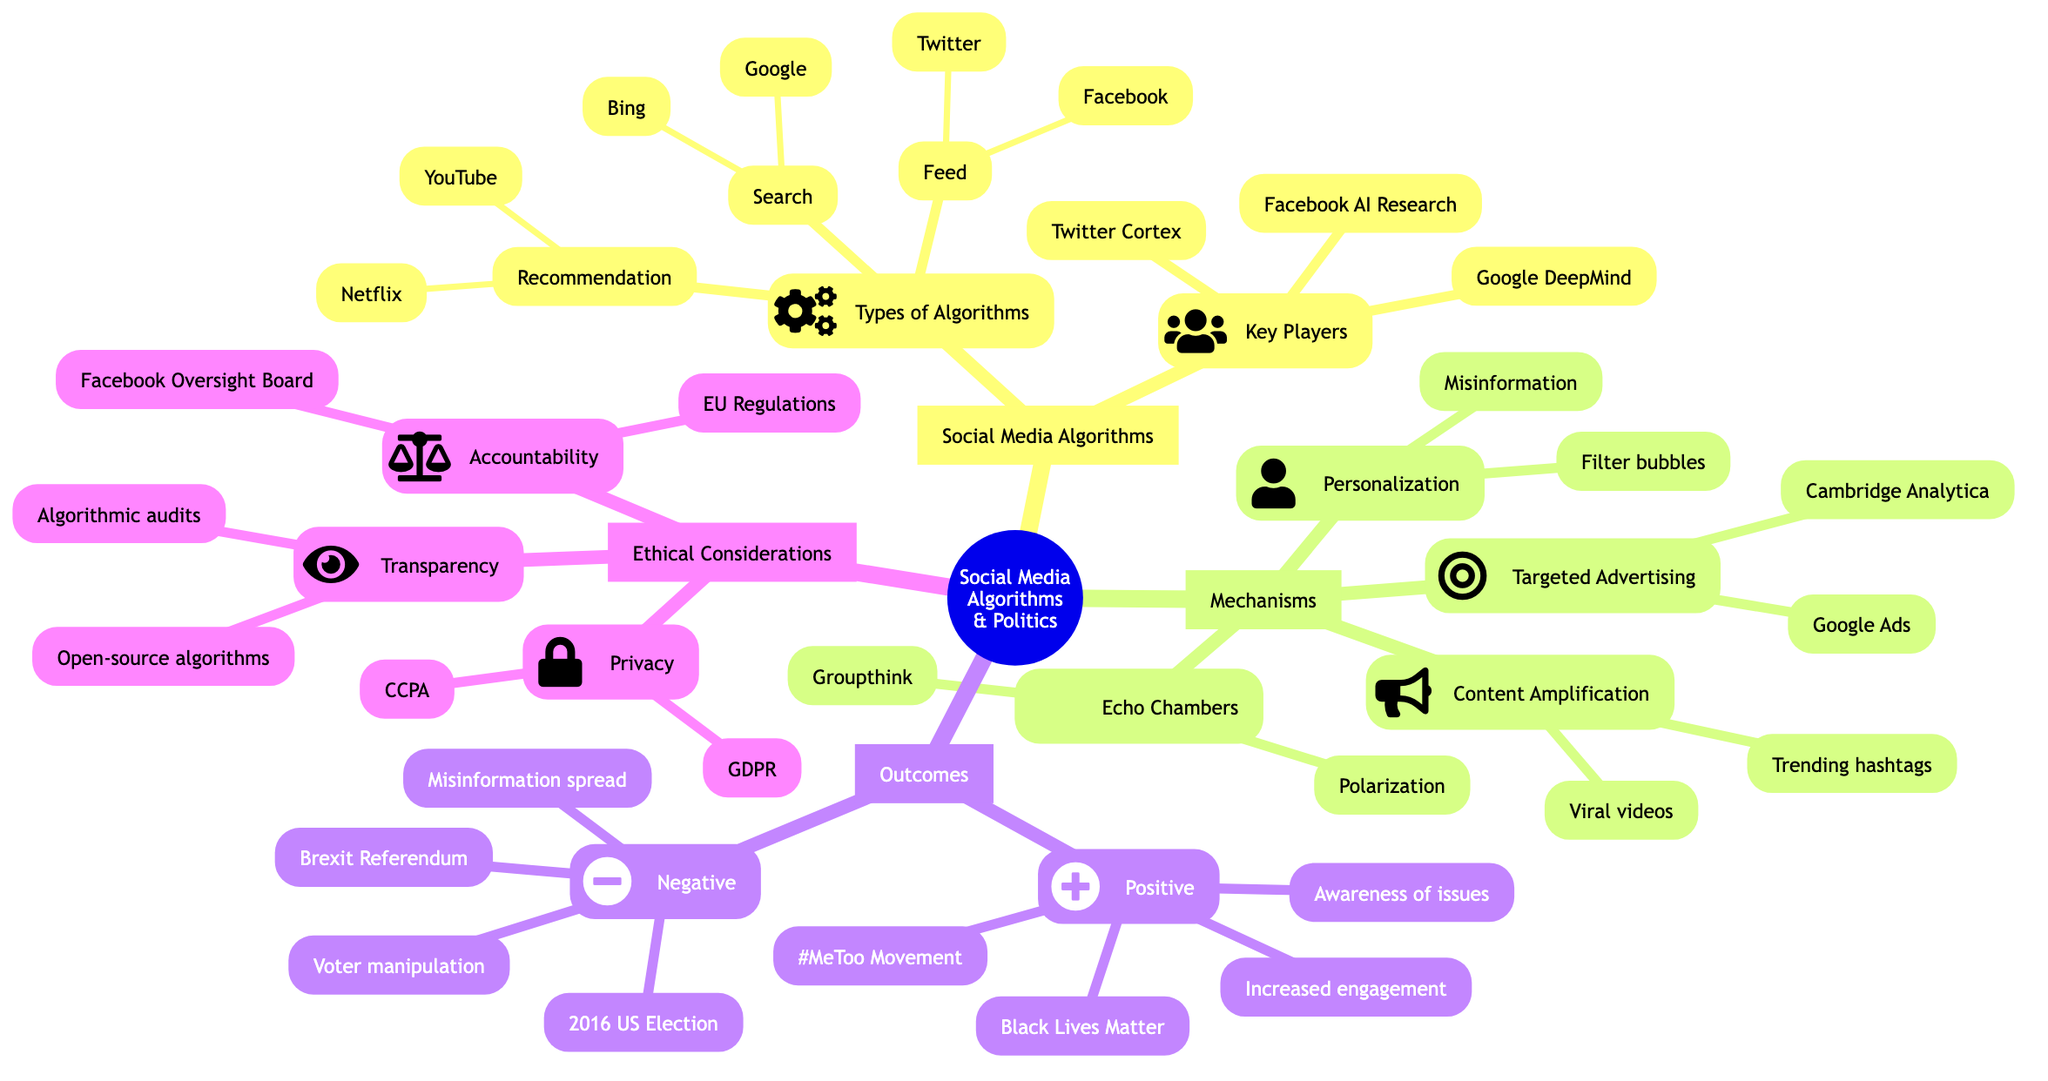What are the types of algorithms listed under social media algorithms? The subnodes under "Types of Algorithms" are "Recommendation Algorithms," "Search Algorithms," and "Feed Algorithms." These are explicitly stated under the node "Types of Algorithms."
Answer: Recommendation Algorithms, Search Algorithms, Feed Algorithms Which platforms are associated with recommendation algorithms? The diagram specifies "YouTube" and "Netflix" as platforms that use recommendation algorithms listed under the "Types of Algorithms" node and its subnode "Recommendation Algorithms."
Answer: YouTube, Netflix What is one example of content amplification mentioned in the diagram? The diagram lists examples under "Content Amplification," specifying "Trending hashtags on Twitter" and "Viral videos on YouTube." As the question asks for one example, either could suffice, but we'll choose the first one as listed.
Answer: Trending hashtags on Twitter What are the two negative outcomes associated with algorithmic influence on political movements? The subnode under "Negative Outcomes" lists "Spread of misinformation" and "Manipulation of voter behavior." Both are specified directly under the corresponding node.
Answer: Spread of misinformation, Manipulation of voter behavior What ethical consideration is focused on user data protection? Under "Ethical Considerations," the subnode "Privacy" explicitly mentions user data protection, which is the focus of this node. This is clearly stated, making it straightforward to answer.
Answer: Privacy How many key players are listed under social media algorithms? The "Key Players" node contains three entities: "Facebook AI Research," "Google DeepMind," and "Twitter Cortex." Counting these entities gives the total number of key players.
Answer: 3 Which case study examples are provided under positive outcomes? The examples listed under "Positive Outcomes" include "#MeToo Movement" and "Black Lives Matter." Both are explicitly stated under this node, indicating the positive case studies.
Answer: #MeToo Movement, Black Lives Matter What suggestion is made regarding transparency in ethical considerations? The node for "Transparency" under "Ethical Considerations" suggests "Algorithmic audits" and "Open-source algorithms" as ways to improve transparency, specifically stating these suggestions.
Answer: Algorithmic audits, Open-source algorithms What description is given for echo chambers? The "Echo Chambers" subnode describes how algorithms reinforce users' pre-existing beliefs, which leads to effects like polarization and groupthink. This description is explicitly provided in the diagram.
Answer: Algorithms reinforcing users' pre-existing beliefs 